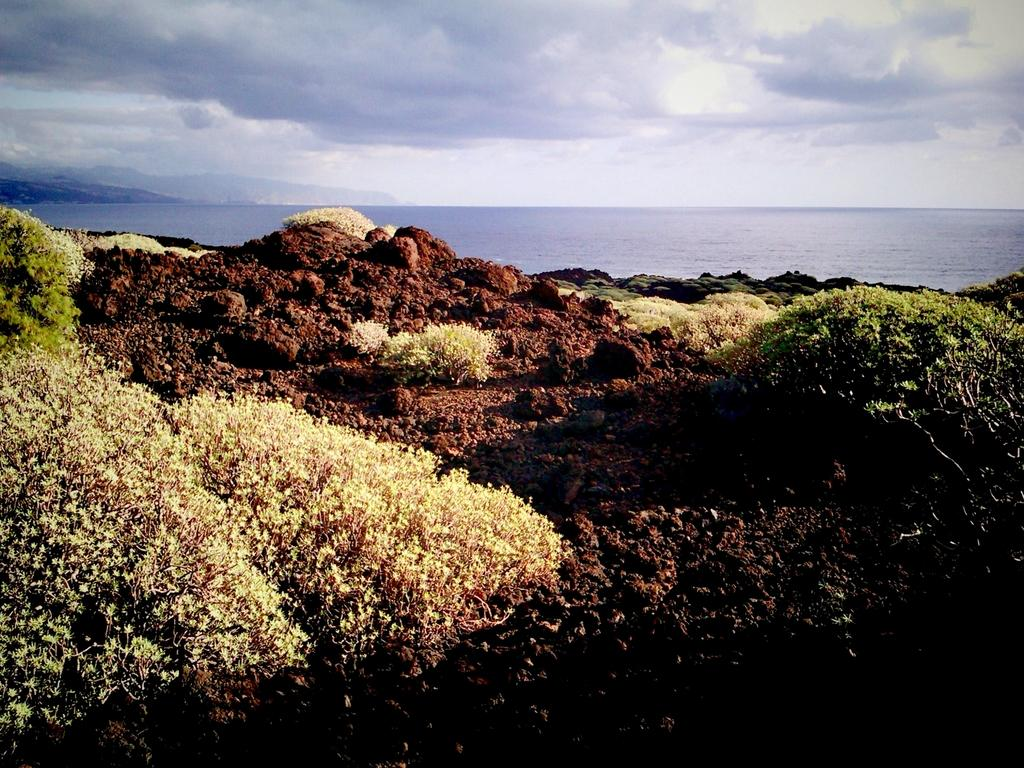What type of vegetation is present at the bottom of the image? There are small plants on the ground at the bottom of the image. What else can be seen on the ground at the bottom of the image? There are stones on the ground at the bottom of the image. What is visible behind the ground in the image? Water is visible behind the ground in the image. What is visible at the top of the image? The sky is visible at the top of the image. What can be seen in the sky in the image? There are clouds in the sky in the image. How many rabbits are walking on the square in the image? There are no rabbits or squares present in the image. 